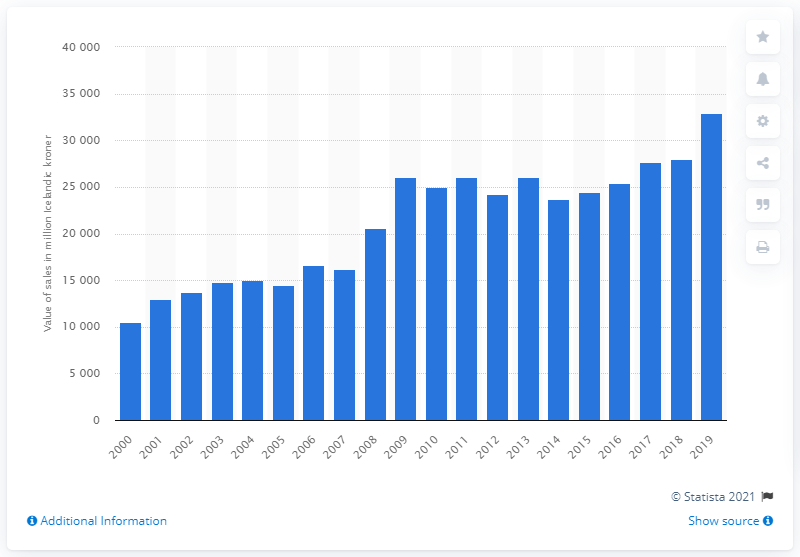Outline some significant characteristics in this image. The total value of pharmaceutical sales in Iceland in 2019 was 32,871 units. Pharmaceutical sales in Iceland in 2000 were valued at 10,463. 